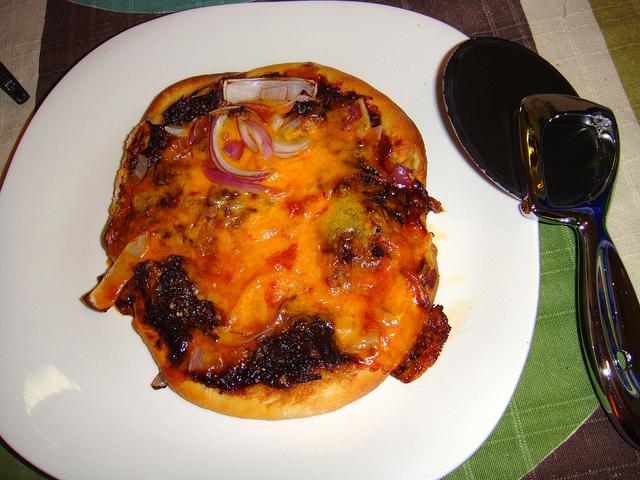What utensil can be seen?
Keep it brief. Spoon. Are there onions in the pizza?
Give a very brief answer. Yes. What silverware is on the plate?
Short answer required. Spoon. What kind of meat is this?
Be succinct. Chicken. Is the plate blue?
Give a very brief answer. No. What color is dominant?
Answer briefly. Orange. Has this food been sliced?
Keep it brief. No. What is on the right of the plate?
Write a very short answer. Spoon. 